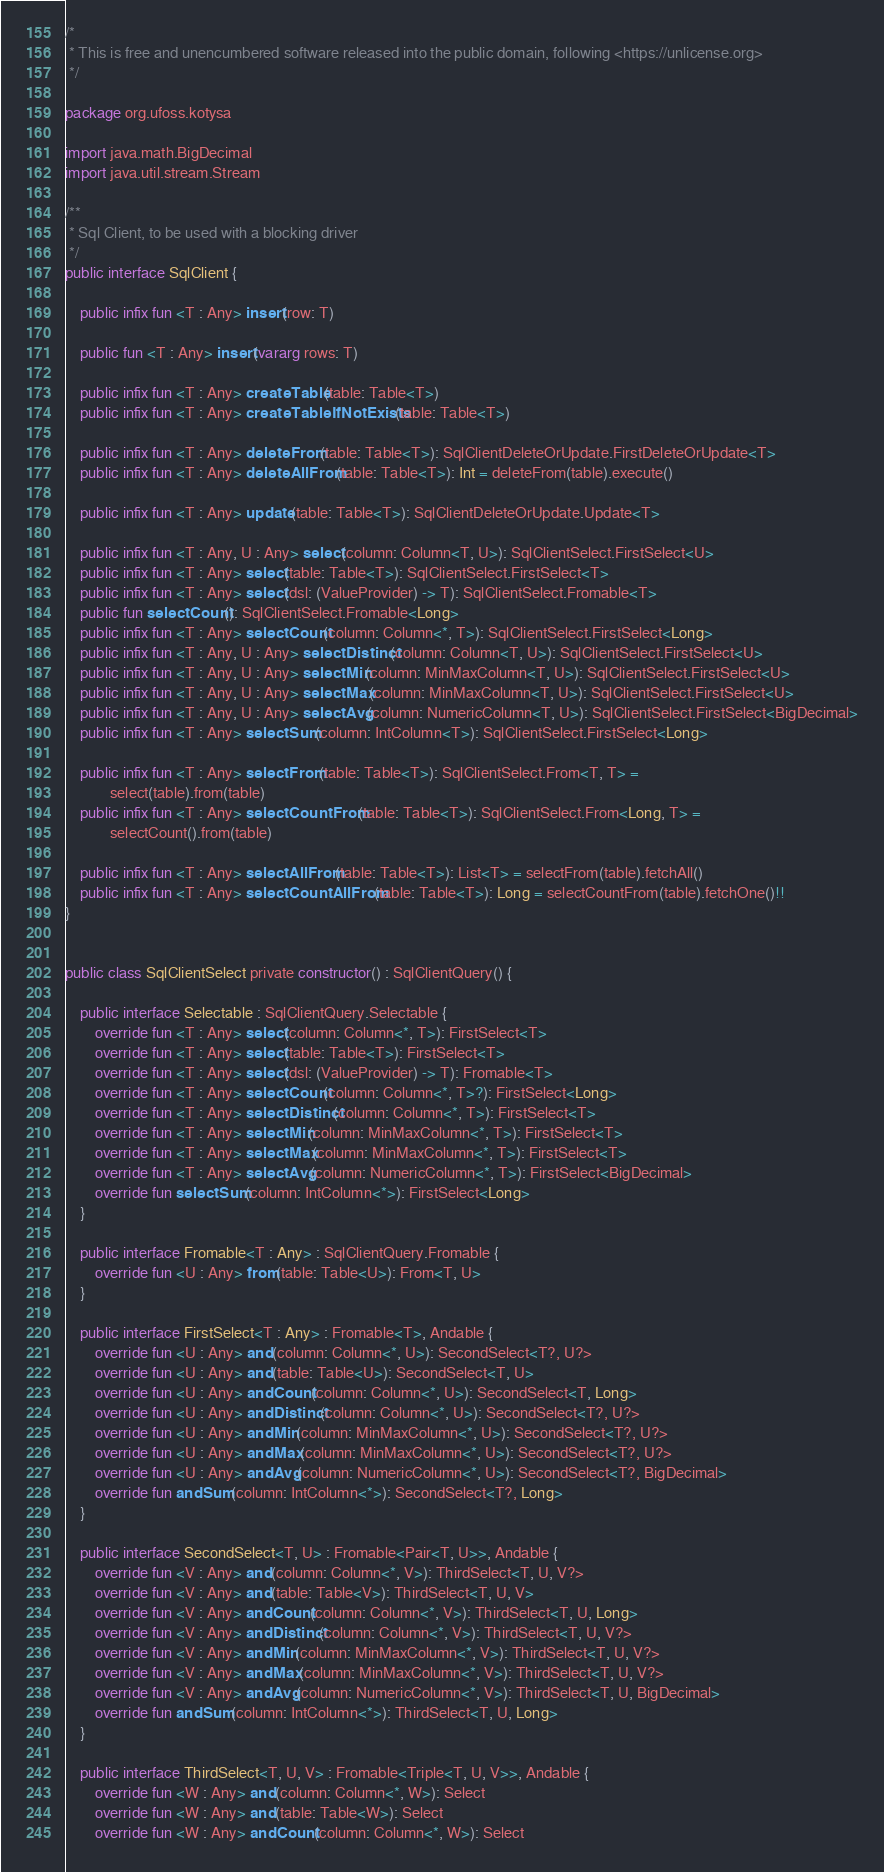Convert code to text. <code><loc_0><loc_0><loc_500><loc_500><_Kotlin_>/*
 * This is free and unencumbered software released into the public domain, following <https://unlicense.org>
 */

package org.ufoss.kotysa

import java.math.BigDecimal
import java.util.stream.Stream

/**
 * Sql Client, to be used with a blocking driver
 */
public interface SqlClient {

    public infix fun <T : Any> insert(row: T)

    public fun <T : Any> insert(vararg rows: T)

    public infix fun <T : Any> createTable(table: Table<T>)
    public infix fun <T : Any> createTableIfNotExists(table: Table<T>)

    public infix fun <T : Any> deleteFrom(table: Table<T>): SqlClientDeleteOrUpdate.FirstDeleteOrUpdate<T>
    public infix fun <T : Any> deleteAllFrom(table: Table<T>): Int = deleteFrom(table).execute()

    public infix fun <T : Any> update(table: Table<T>): SqlClientDeleteOrUpdate.Update<T>

    public infix fun <T : Any, U : Any> select(column: Column<T, U>): SqlClientSelect.FirstSelect<U>
    public infix fun <T : Any> select(table: Table<T>): SqlClientSelect.FirstSelect<T>
    public infix fun <T : Any> select(dsl: (ValueProvider) -> T): SqlClientSelect.Fromable<T>
    public fun selectCount(): SqlClientSelect.Fromable<Long>
    public infix fun <T : Any> selectCount(column: Column<*, T>): SqlClientSelect.FirstSelect<Long>
    public infix fun <T : Any, U : Any> selectDistinct(column: Column<T, U>): SqlClientSelect.FirstSelect<U>
    public infix fun <T : Any, U : Any> selectMin(column: MinMaxColumn<T, U>): SqlClientSelect.FirstSelect<U>
    public infix fun <T : Any, U : Any> selectMax(column: MinMaxColumn<T, U>): SqlClientSelect.FirstSelect<U>
    public infix fun <T : Any, U : Any> selectAvg(column: NumericColumn<T, U>): SqlClientSelect.FirstSelect<BigDecimal>
    public infix fun <T : Any> selectSum(column: IntColumn<T>): SqlClientSelect.FirstSelect<Long>

    public infix fun <T : Any> selectFrom(table: Table<T>): SqlClientSelect.From<T, T> =
            select(table).from(table)
    public infix fun <T : Any> selectCountFrom(table: Table<T>): SqlClientSelect.From<Long, T> =
            selectCount().from(table)

    public infix fun <T : Any> selectAllFrom(table: Table<T>): List<T> = selectFrom(table).fetchAll()
    public infix fun <T : Any> selectCountAllFrom(table: Table<T>): Long = selectCountFrom(table).fetchOne()!!
}


public class SqlClientSelect private constructor() : SqlClientQuery() {

    public interface Selectable : SqlClientQuery.Selectable {
        override fun <T : Any> select(column: Column<*, T>): FirstSelect<T>
        override fun <T : Any> select(table: Table<T>): FirstSelect<T>
        override fun <T : Any> select(dsl: (ValueProvider) -> T): Fromable<T>
        override fun <T : Any> selectCount(column: Column<*, T>?): FirstSelect<Long>
        override fun <T : Any> selectDistinct(column: Column<*, T>): FirstSelect<T>
        override fun <T : Any> selectMin(column: MinMaxColumn<*, T>): FirstSelect<T>
        override fun <T : Any> selectMax(column: MinMaxColumn<*, T>): FirstSelect<T>
        override fun <T : Any> selectAvg(column: NumericColumn<*, T>): FirstSelect<BigDecimal>
        override fun selectSum(column: IntColumn<*>): FirstSelect<Long>
    }

    public interface Fromable<T : Any> : SqlClientQuery.Fromable {
        override fun <U : Any> from(table: Table<U>): From<T, U>
    }

    public interface FirstSelect<T : Any> : Fromable<T>, Andable {
        override fun <U : Any> and(column: Column<*, U>): SecondSelect<T?, U?>
        override fun <U : Any> and(table: Table<U>): SecondSelect<T, U>
        override fun <U : Any> andCount(column: Column<*, U>): SecondSelect<T, Long>
        override fun <U : Any> andDistinct(column: Column<*, U>): SecondSelect<T?, U?>
        override fun <U : Any> andMin(column: MinMaxColumn<*, U>): SecondSelect<T?, U?>
        override fun <U : Any> andMax(column: MinMaxColumn<*, U>): SecondSelect<T?, U?>
        override fun <U : Any> andAvg(column: NumericColumn<*, U>): SecondSelect<T?, BigDecimal>
        override fun andSum(column: IntColumn<*>): SecondSelect<T?, Long>
    }

    public interface SecondSelect<T, U> : Fromable<Pair<T, U>>, Andable {
        override fun <V : Any> and(column: Column<*, V>): ThirdSelect<T, U, V?>
        override fun <V : Any> and(table: Table<V>): ThirdSelect<T, U, V>
        override fun <V : Any> andCount(column: Column<*, V>): ThirdSelect<T, U, Long>
        override fun <V : Any> andDistinct(column: Column<*, V>): ThirdSelect<T, U, V?>
        override fun <V : Any> andMin(column: MinMaxColumn<*, V>): ThirdSelect<T, U, V?>
        override fun <V : Any> andMax(column: MinMaxColumn<*, V>): ThirdSelect<T, U, V?>
        override fun <V : Any> andAvg(column: NumericColumn<*, V>): ThirdSelect<T, U, BigDecimal>
        override fun andSum(column: IntColumn<*>): ThirdSelect<T, U, Long>
    }

    public interface ThirdSelect<T, U, V> : Fromable<Triple<T, U, V>>, Andable {
        override fun <W : Any> and(column: Column<*, W>): Select
        override fun <W : Any> and(table: Table<W>): Select
        override fun <W : Any> andCount(column: Column<*, W>): Select</code> 